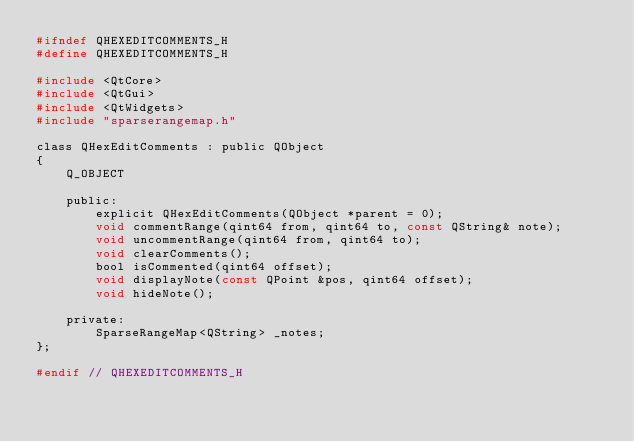<code> <loc_0><loc_0><loc_500><loc_500><_C_>#ifndef QHEXEDITCOMMENTS_H
#define QHEXEDITCOMMENTS_H

#include <QtCore>
#include <QtGui>
#include <QtWidgets>
#include "sparserangemap.h"

class QHexEditComments : public QObject
{
    Q_OBJECT

    public:
        explicit QHexEditComments(QObject *parent = 0);
        void commentRange(qint64 from, qint64 to, const QString& note);
        void uncommentRange(qint64 from, qint64 to);
        void clearComments();
        bool isCommented(qint64 offset);
        void displayNote(const QPoint &pos, qint64 offset);
        void hideNote();

    private:
        SparseRangeMap<QString> _notes;
};

#endif // QHEXEDITCOMMENTS_H
</code> 